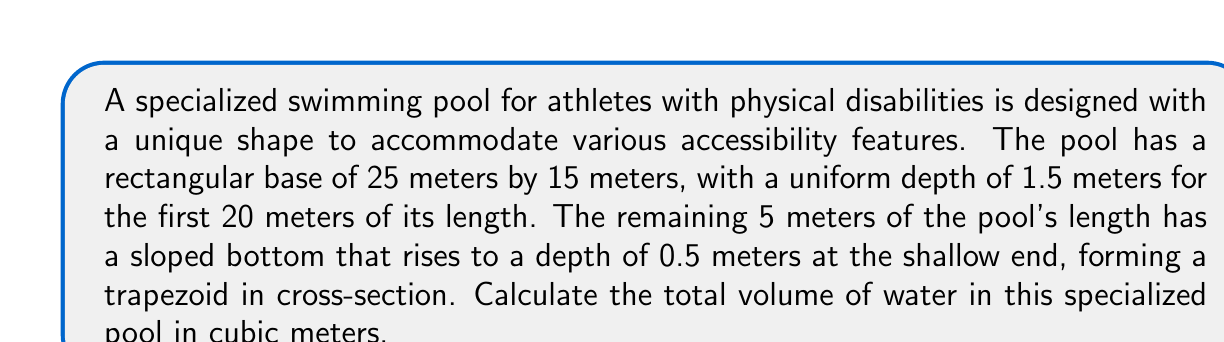What is the answer to this math problem? Let's approach this problem step by step:

1) First, we'll calculate the volume of the rectangular part of the pool:
   $$V_1 = l_1 \times w \times d_1$$
   Where $l_1 = 20$ m, $w = 15$ m, and $d_1 = 1.5$ m
   $$V_1 = 20 \times 15 \times 1.5 = 450 \text{ m}^3$$

2) For the sloped part, we need to calculate the volume of a trapezoidal prism:
   $$V_2 = \frac{1}{2}(d_1 + d_2) \times l_2 \times w$$
   Where $d_1 = 1.5$ m, $d_2 = 0.5$ m, $l_2 = 5$ m, and $w = 15$ m
   $$V_2 = \frac{1}{2}(1.5 + 0.5) \times 5 \times 15 = 75 \text{ m}^3$$

3) The total volume is the sum of these two parts:
   $$V_{\text{total}} = V_1 + V_2 = 450 + 75 = 525 \text{ m}^3$$

[asy]
import three;

size(200);
currentprojection=perspective(6,3,2);

path3 base=scale(25,15,0)*unitsquare;
path3 top=shift(0,0,1.5)*scale(20,15,0)*unitsquare;
path3 slope=shift(20,0,0)*scale(5,15,1.5)*path3((0,0,0)--(1,0,0)--(1,1,-2/3)--(0,1,-2/3)--cycle);

draw(surface(base),paleblue+opacity(0.3));
draw(surface(top),paleblue+opacity(0.3));
draw(surface(slope),paleblue+opacity(0.3));

draw(base,blue);
draw(top,blue);
draw(slope,blue);

label("25 m",point(base,E),E);
label("15 m",point(base,N),N);
label("1.5 m",point(top,SW),SW);
label("0.5 m",point(slope,SE),SE);
label("20 m",point(top,S),S);
label("5 m",point(slope,S),S);
[/asy]
Answer: The total volume of water in the specialized swimming pool is 525 cubic meters. 